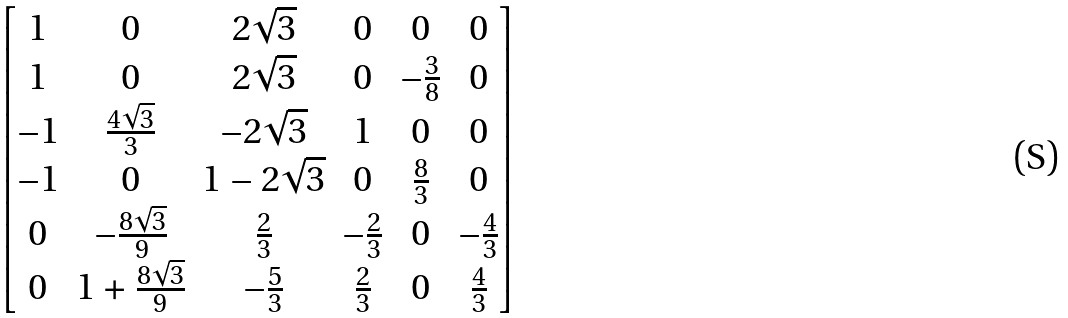<formula> <loc_0><loc_0><loc_500><loc_500>\begin{bmatrix} 1 & 0 & 2 \sqrt { 3 } & 0 & 0 & 0 \\ 1 & 0 & 2 \sqrt { 3 } & 0 & - \frac { 3 } { 8 } & 0 \\ - 1 & \frac { 4 \sqrt { 3 } } { 3 } & - 2 \sqrt { 3 } & 1 & 0 & 0 \\ - 1 & 0 & 1 - 2 \sqrt { 3 } & 0 & \frac { 8 } { 3 } & 0 \\ 0 & - \frac { 8 \sqrt { 3 } } { 9 } & \frac { 2 } { 3 } & - \frac { 2 } { 3 } & 0 & - \frac { 4 } { 3 } \\ 0 & 1 + \frac { 8 \sqrt { 3 } } { 9 } & - \frac { 5 } { 3 } & \frac { 2 } { 3 } & 0 & \frac { 4 } { 3 } \end{bmatrix}</formula> 